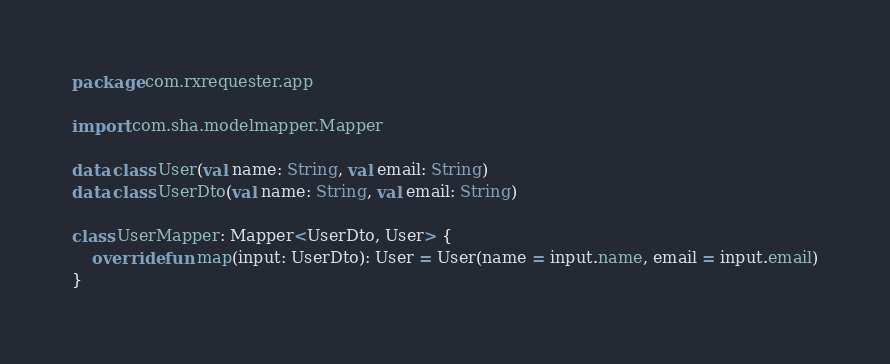Convert code to text. <code><loc_0><loc_0><loc_500><loc_500><_Kotlin_>package com.rxrequester.app

import com.sha.modelmapper.Mapper

data class User(val name: String, val email: String)
data class UserDto(val name: String, val email: String)

class UserMapper: Mapper<UserDto, User> {
    override fun map(input: UserDto): User = User(name = input.name, email = input.email)
}</code> 